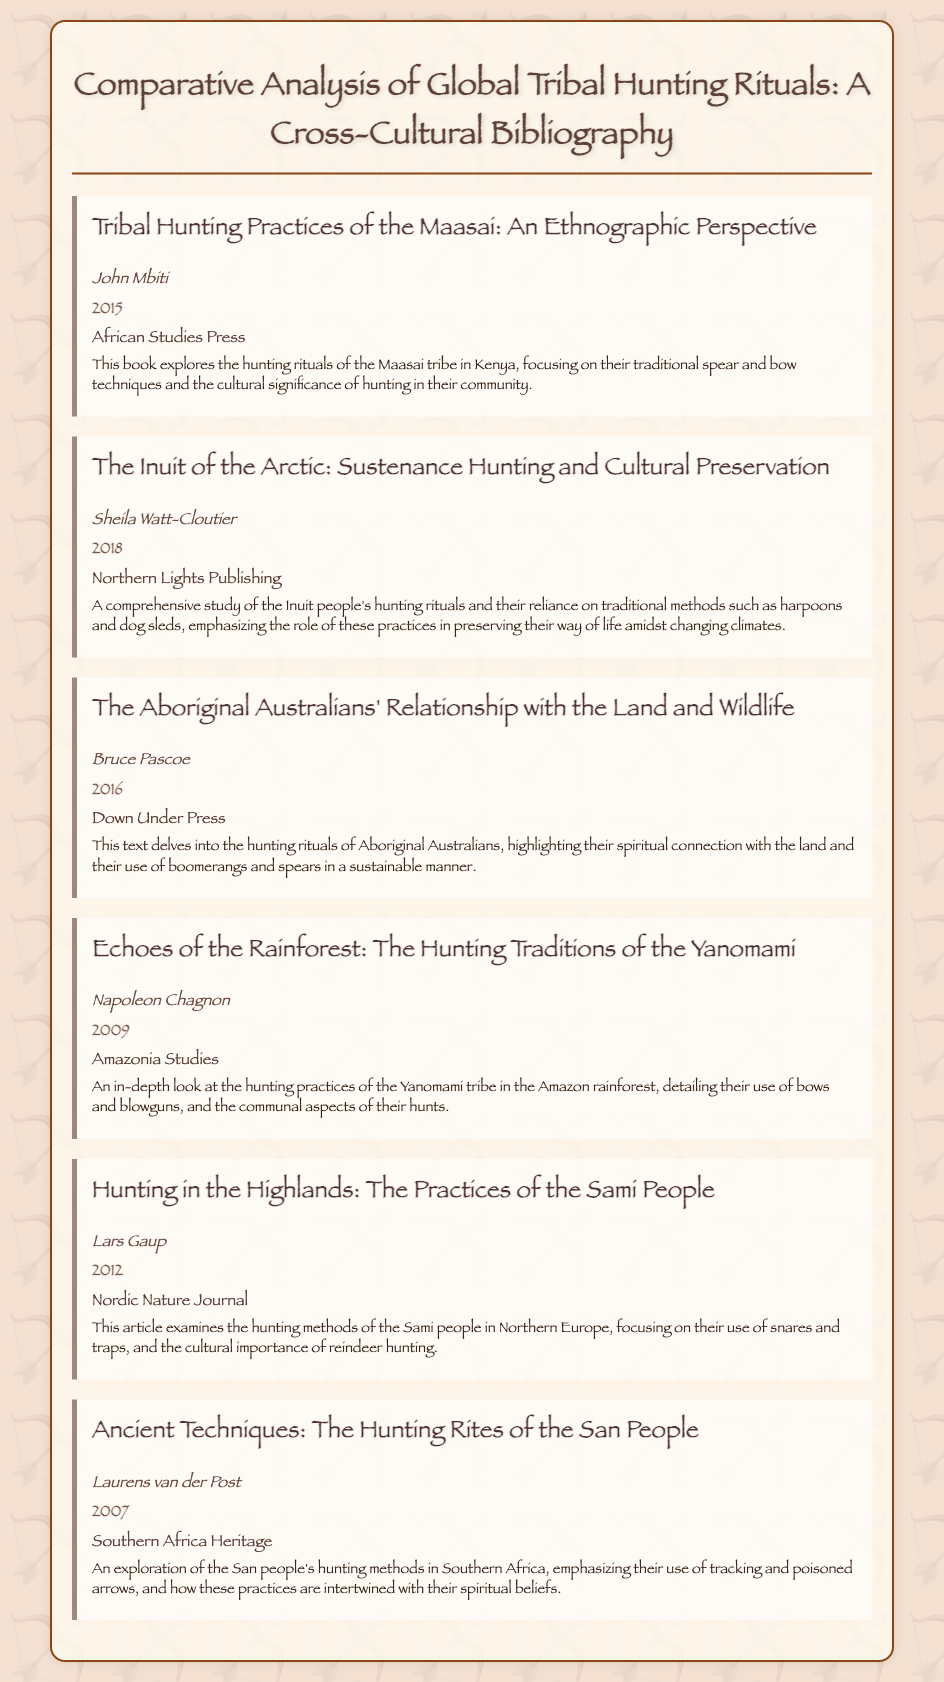What is the title of the first entry? The title is explicitly stated at the beginning of the entry labeled for the Maasai tribe.
Answer: Tribal Hunting Practices of the Maasai: An Ethnographic Perspective Who is the author of the book on Inuit hunting rituals? The author is clearly indicated in the entry about the Inuit hunting practices.
Answer: Sheila Watt-Cloutier What year was the book on Aboriginal Australians published? The publication year is included in the entry for the Aboriginal Australians' relationship with land and wildlife.
Answer: 2016 Which tribe's hunting practices are detailed in the entry authored by Napoleon Chagnon? The title of the entry allows us to identify the tribe discussed by the author.
Answer: Yanomami What is one method used by the Sami people for hunting as described in the document? The document specifies the Sami people's hunting methods in the relevant entry.
Answer: Snares and traps Which publisher released the book about the San people's hunting rites? The publisher name is presented in the entry for the San people's practices.
Answer: Southern Africa Heritage What cultural significance is highlighted in the description of the Maasai hunting rituals? The description emphasizes the cultural significance of hunting in the Maasai community.
Answer: Cultural significance of hunting How many entries discuss bow and arrow techniques? The entries provide details on various tribes that utilize bows in their hunting practices.
Answer: Three 